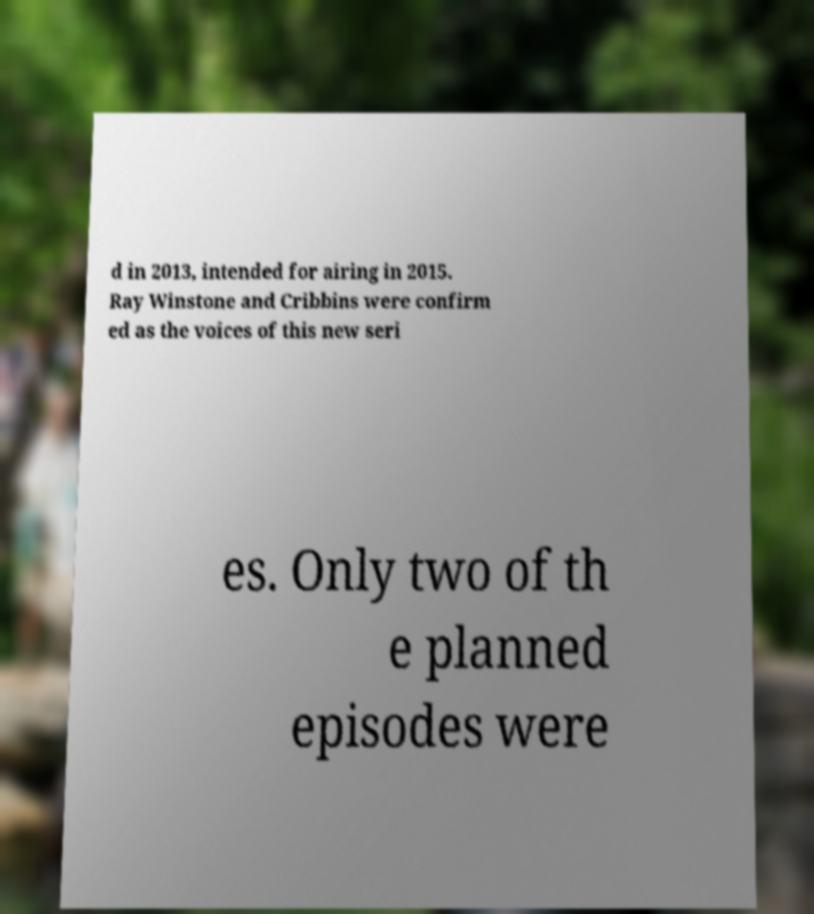I need the written content from this picture converted into text. Can you do that? d in 2013, intended for airing in 2015. Ray Winstone and Cribbins were confirm ed as the voices of this new seri es. Only two of th e planned episodes were 